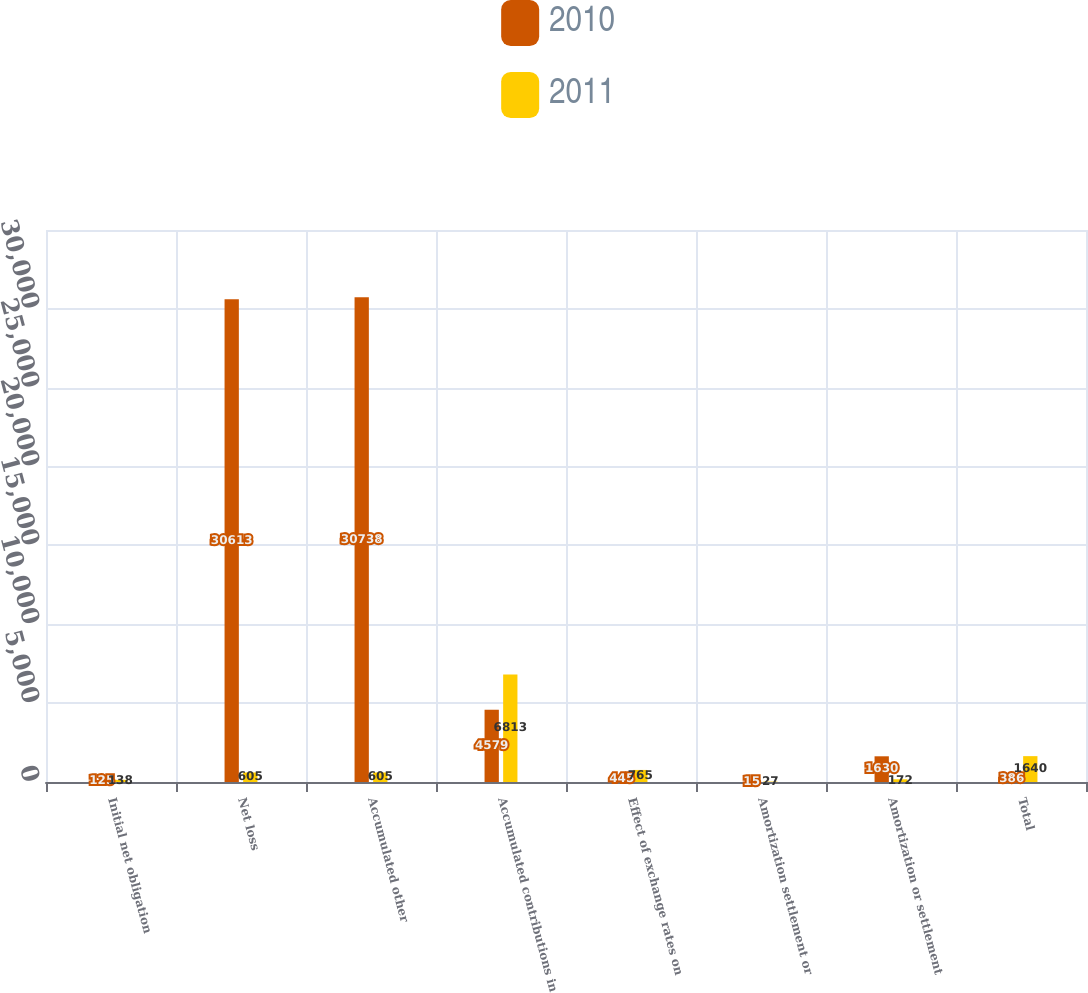Convert chart. <chart><loc_0><loc_0><loc_500><loc_500><stacked_bar_chart><ecel><fcel>Initial net obligation<fcel>Net loss<fcel>Accumulated other<fcel>Accumulated contributions in<fcel>Effect of exchange rates on<fcel>Amortization settlement or<fcel>Amortization or settlement<fcel>Total<nl><fcel>2010<fcel>125<fcel>30613<fcel>30738<fcel>4579<fcel>445<fcel>15<fcel>1630<fcel>386<nl><fcel>2011<fcel>138<fcel>605<fcel>605<fcel>6813<fcel>765<fcel>27<fcel>172<fcel>1640<nl></chart> 